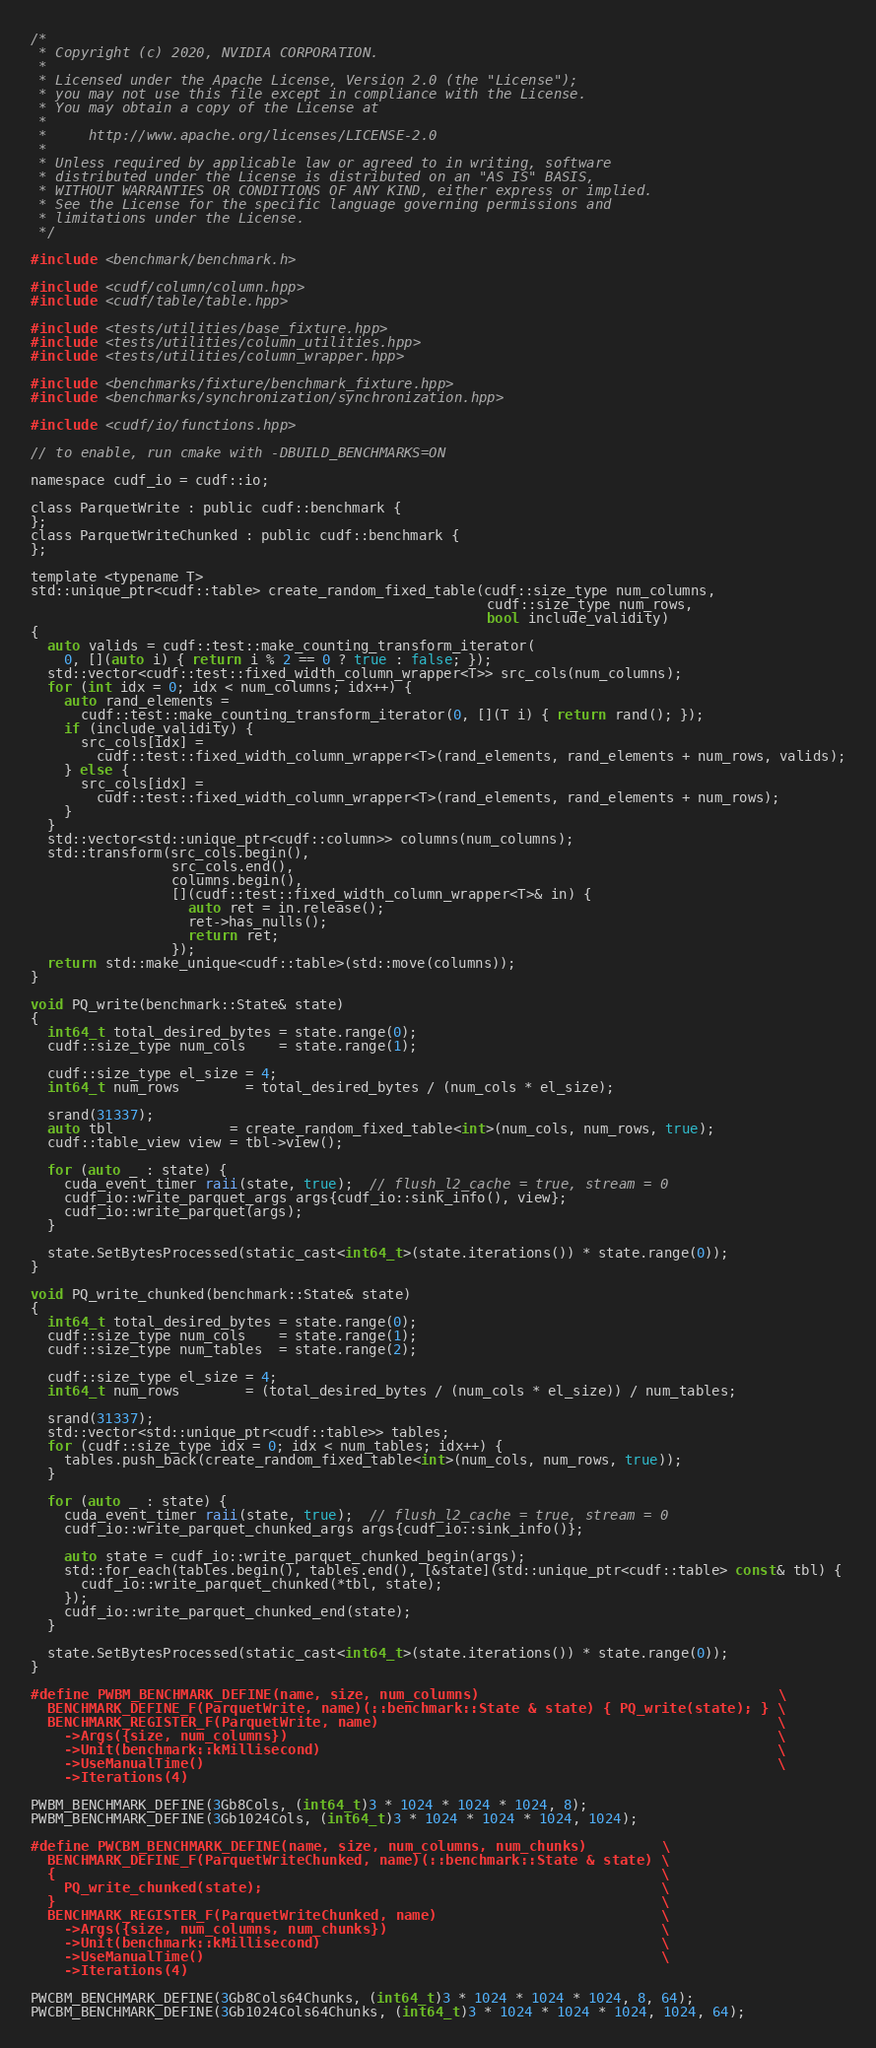Convert code to text. <code><loc_0><loc_0><loc_500><loc_500><_Cuda_>/*
 * Copyright (c) 2020, NVIDIA CORPORATION.
 *
 * Licensed under the Apache License, Version 2.0 (the "License");
 * you may not use this file except in compliance with the License.
 * You may obtain a copy of the License at
 *
 *     http://www.apache.org/licenses/LICENSE-2.0
 *
 * Unless required by applicable law or agreed to in writing, software
 * distributed under the License is distributed on an "AS IS" BASIS,
 * WITHOUT WARRANTIES OR CONDITIONS OF ANY KIND, either express or implied.
 * See the License for the specific language governing permissions and
 * limitations under the License.
 */

#include <benchmark/benchmark.h>

#include <cudf/column/column.hpp>
#include <cudf/table/table.hpp>

#include <tests/utilities/base_fixture.hpp>
#include <tests/utilities/column_utilities.hpp>
#include <tests/utilities/column_wrapper.hpp>

#include <benchmarks/fixture/benchmark_fixture.hpp>
#include <benchmarks/synchronization/synchronization.hpp>

#include <cudf/io/functions.hpp>

// to enable, run cmake with -DBUILD_BENCHMARKS=ON

namespace cudf_io = cudf::io;

class ParquetWrite : public cudf::benchmark {
};
class ParquetWriteChunked : public cudf::benchmark {
};

template <typename T>
std::unique_ptr<cudf::table> create_random_fixed_table(cudf::size_type num_columns,
                                                       cudf::size_type num_rows,
                                                       bool include_validity)
{
  auto valids = cudf::test::make_counting_transform_iterator(
    0, [](auto i) { return i % 2 == 0 ? true : false; });
  std::vector<cudf::test::fixed_width_column_wrapper<T>> src_cols(num_columns);
  for (int idx = 0; idx < num_columns; idx++) {
    auto rand_elements =
      cudf::test::make_counting_transform_iterator(0, [](T i) { return rand(); });
    if (include_validity) {
      src_cols[idx] =
        cudf::test::fixed_width_column_wrapper<T>(rand_elements, rand_elements + num_rows, valids);
    } else {
      src_cols[idx] =
        cudf::test::fixed_width_column_wrapper<T>(rand_elements, rand_elements + num_rows);
    }
  }
  std::vector<std::unique_ptr<cudf::column>> columns(num_columns);
  std::transform(src_cols.begin(),
                 src_cols.end(),
                 columns.begin(),
                 [](cudf::test::fixed_width_column_wrapper<T>& in) {
                   auto ret = in.release();
                   ret->has_nulls();
                   return ret;
                 });
  return std::make_unique<cudf::table>(std::move(columns));
}

void PQ_write(benchmark::State& state)
{
  int64_t total_desired_bytes = state.range(0);
  cudf::size_type num_cols    = state.range(1);

  cudf::size_type el_size = 4;
  int64_t num_rows        = total_desired_bytes / (num_cols * el_size);

  srand(31337);
  auto tbl              = create_random_fixed_table<int>(num_cols, num_rows, true);
  cudf::table_view view = tbl->view();

  for (auto _ : state) {
    cuda_event_timer raii(state, true);  // flush_l2_cache = true, stream = 0
    cudf_io::write_parquet_args args{cudf_io::sink_info(), view};
    cudf_io::write_parquet(args);
  }

  state.SetBytesProcessed(static_cast<int64_t>(state.iterations()) * state.range(0));
}

void PQ_write_chunked(benchmark::State& state)
{
  int64_t total_desired_bytes = state.range(0);
  cudf::size_type num_cols    = state.range(1);
  cudf::size_type num_tables  = state.range(2);

  cudf::size_type el_size = 4;
  int64_t num_rows        = (total_desired_bytes / (num_cols * el_size)) / num_tables;

  srand(31337);
  std::vector<std::unique_ptr<cudf::table>> tables;
  for (cudf::size_type idx = 0; idx < num_tables; idx++) {
    tables.push_back(create_random_fixed_table<int>(num_cols, num_rows, true));
  }

  for (auto _ : state) {
    cuda_event_timer raii(state, true);  // flush_l2_cache = true, stream = 0
    cudf_io::write_parquet_chunked_args args{cudf_io::sink_info()};

    auto state = cudf_io::write_parquet_chunked_begin(args);
    std::for_each(tables.begin(), tables.end(), [&state](std::unique_ptr<cudf::table> const& tbl) {
      cudf_io::write_parquet_chunked(*tbl, state);
    });
    cudf_io::write_parquet_chunked_end(state);
  }

  state.SetBytesProcessed(static_cast<int64_t>(state.iterations()) * state.range(0));
}

#define PWBM_BENCHMARK_DEFINE(name, size, num_columns)                                    \
  BENCHMARK_DEFINE_F(ParquetWrite, name)(::benchmark::State & state) { PQ_write(state); } \
  BENCHMARK_REGISTER_F(ParquetWrite, name)                                                \
    ->Args({size, num_columns})                                                           \
    ->Unit(benchmark::kMillisecond)                                                       \
    ->UseManualTime()                                                                     \
    ->Iterations(4)

PWBM_BENCHMARK_DEFINE(3Gb8Cols, (int64_t)3 * 1024 * 1024 * 1024, 8);
PWBM_BENCHMARK_DEFINE(3Gb1024Cols, (int64_t)3 * 1024 * 1024 * 1024, 1024);

#define PWCBM_BENCHMARK_DEFINE(name, size, num_columns, num_chunks)         \
  BENCHMARK_DEFINE_F(ParquetWriteChunked, name)(::benchmark::State & state) \
  {                                                                         \
    PQ_write_chunked(state);                                                \
  }                                                                         \
  BENCHMARK_REGISTER_F(ParquetWriteChunked, name)                           \
    ->Args({size, num_columns, num_chunks})                                 \
    ->Unit(benchmark::kMillisecond)                                         \
    ->UseManualTime()                                                       \
    ->Iterations(4)

PWCBM_BENCHMARK_DEFINE(3Gb8Cols64Chunks, (int64_t)3 * 1024 * 1024 * 1024, 8, 64);
PWCBM_BENCHMARK_DEFINE(3Gb1024Cols64Chunks, (int64_t)3 * 1024 * 1024 * 1024, 1024, 64);
</code> 